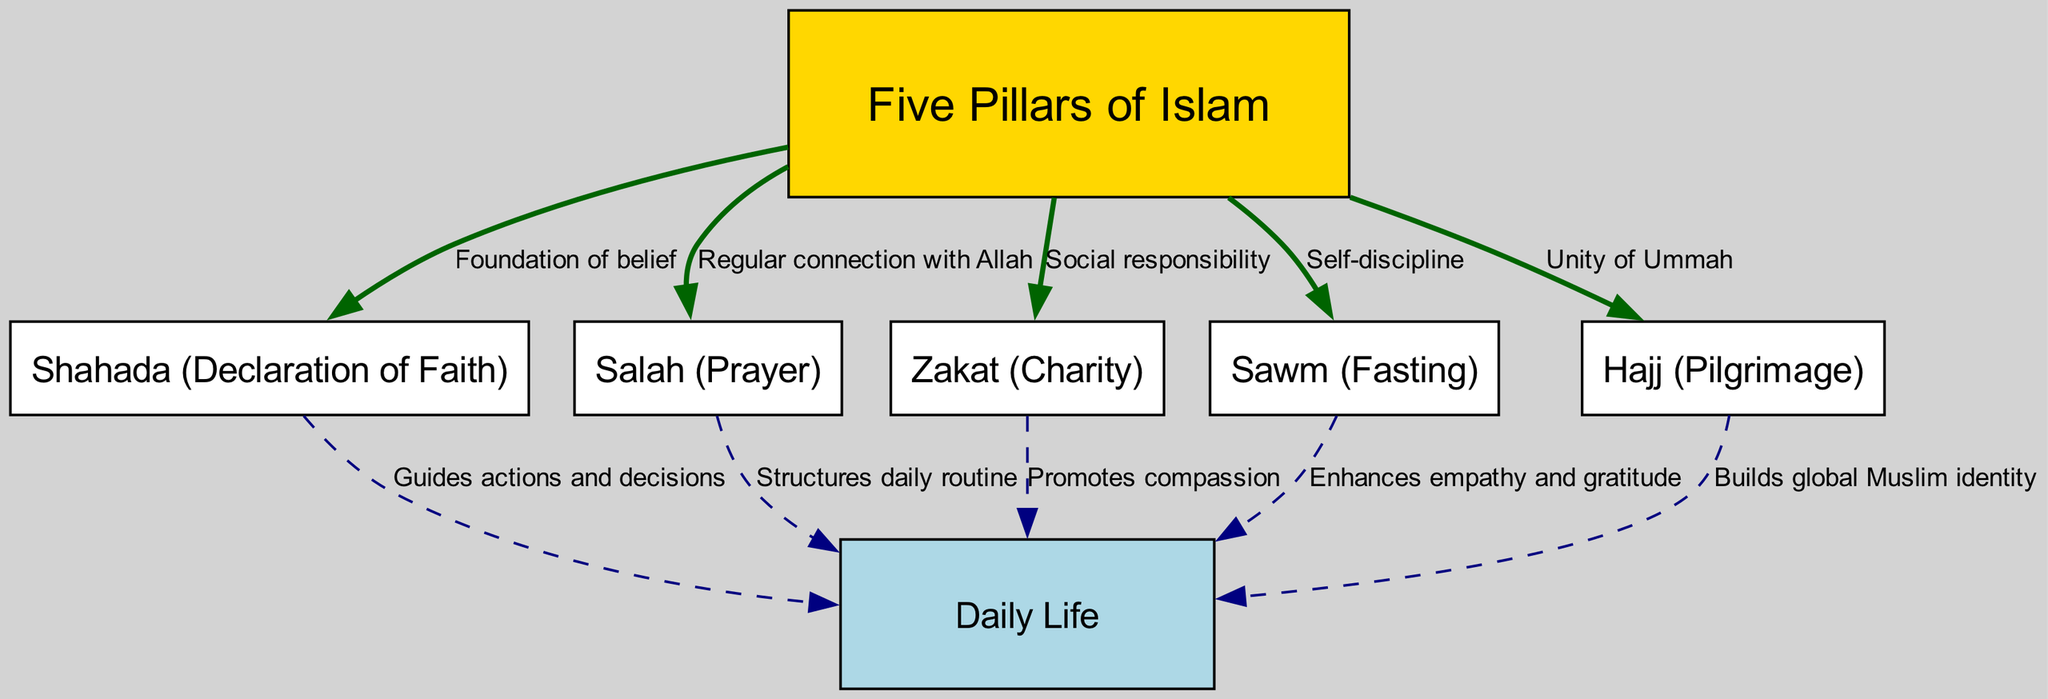What are the Five Pillars of Islam? The diagram lists the Five Pillars of Islam as Shahada, Salah, Zakat, Sawm, and Hajj. These are shown as separate nodes connected to the central node labeled "Five Pillars of Islam."
Answer: Shahada, Salah, Zakat, Sawm, Hajj What does the Shahada represent in the context of the Five Pillars? The Shahada is labeled in the diagram as the "Foundation of belief," indicating its critical role as the first pillar. This establishes the importance of belief in Allah and His Messenger.
Answer: Foundation of belief How does Salah influence daily life? The diagram indicates that Salah "Structures daily routine," showing that it plays a key role in organizing the time and activities of a Muslim's day based on prayer timings.
Answer: Structures daily routine What is the relationship between Zakat and daily life? The diagram shows that Zakat "Promotes compassion." This suggests that regularly giving charity impacts a person's relationship with others and fosters empathy within the community.
Answer: Promotes compassion What do all Five Pillars contribute to daily life? The diagram links each pillar to daily life with specific roles: Shahada guides actions, Salah structures daily routine, Zakat promotes compassion, Sawm enhances empathy, and Hajj builds global Muslim identity. The interconnections show the collective influence of the pillars.
Answer: Collectively guide actions, structure routine, promote compassion, enhance empathy, and build identity How many edges are there connecting the Five Pillars to daily life? By analyzing the edges extending from the "Five Pillars of Islam" node to the "daily life" node, we see five connections, one for each pillar.
Answer: 5 What concept is emphasized by the Hajj in relation to the Ummah? The diagram indicates that Hajj emphasizes the "Unity of Ummah," showing that it promotes a sense of global identity among Muslims and strengthens communal ties.
Answer: Unity of Ummah What impact does Sawm have on a person's feelings? According to the diagram, Sawm "Enhances empathy and gratitude," suggesting that fasting encourages reflection and appreciation for one's blessings, influencing emotions positively.
Answer: Enhances empathy and gratitude What is the main role of Zakat in the community? The diagram states that Zakat's main role is "Social responsibility," highlighting its importance in fostering community support and assisting those in need.
Answer: Social responsibility 